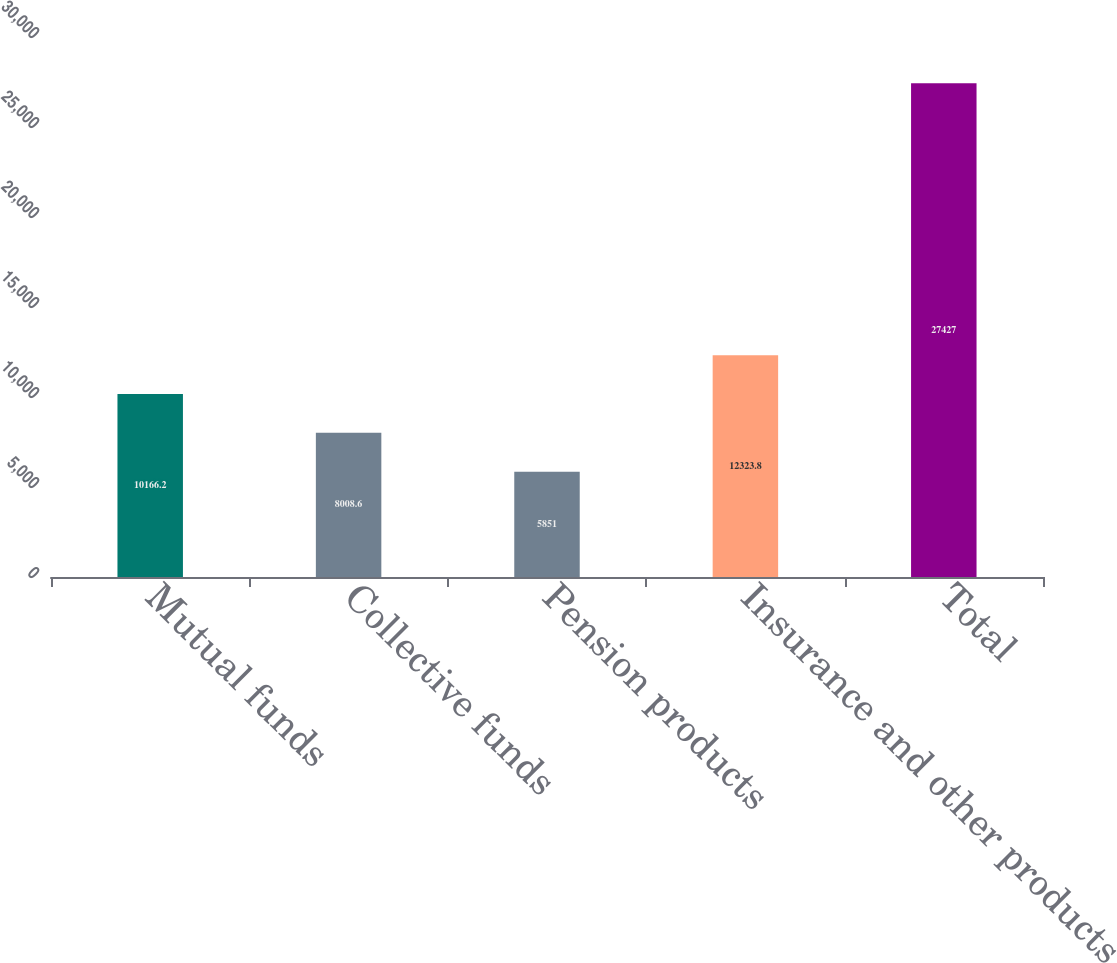Convert chart. <chart><loc_0><loc_0><loc_500><loc_500><bar_chart><fcel>Mutual funds<fcel>Collective funds<fcel>Pension products<fcel>Insurance and other products<fcel>Total<nl><fcel>10166.2<fcel>8008.6<fcel>5851<fcel>12323.8<fcel>27427<nl></chart> 